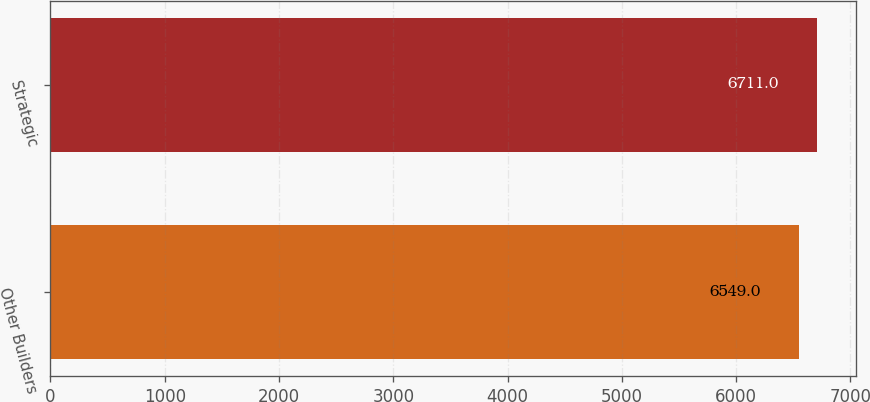Convert chart to OTSL. <chart><loc_0><loc_0><loc_500><loc_500><bar_chart><fcel>Other Builders<fcel>Strategic<nl><fcel>6549<fcel>6711<nl></chart> 